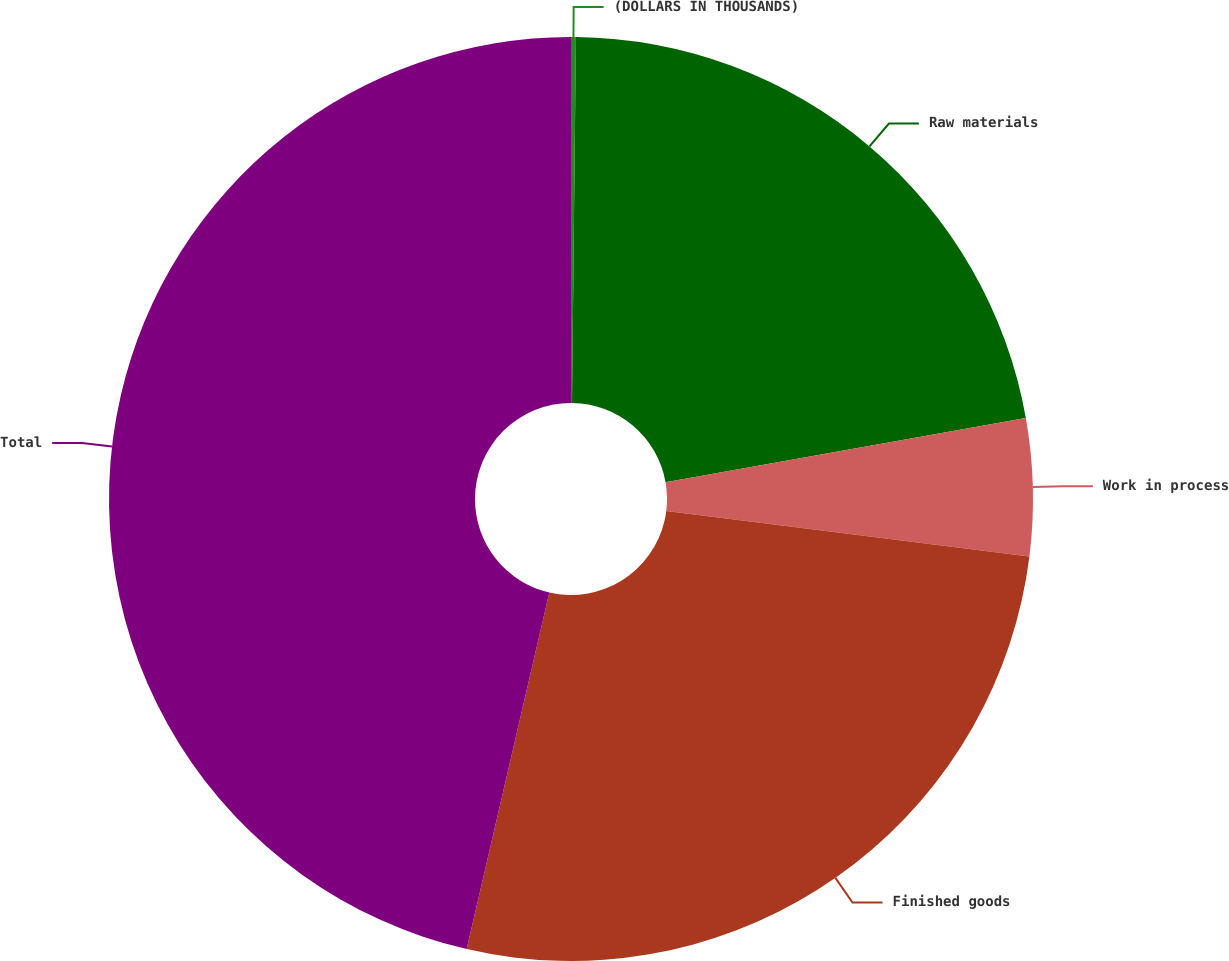Convert chart to OTSL. <chart><loc_0><loc_0><loc_500><loc_500><pie_chart><fcel>(DOLLARS IN THOUSANDS)<fcel>Raw materials<fcel>Work in process<fcel>Finished goods<fcel>Total<nl><fcel>0.17%<fcel>22.02%<fcel>4.79%<fcel>26.64%<fcel>46.37%<nl></chart> 